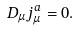Convert formula to latex. <formula><loc_0><loc_0><loc_500><loc_500>D _ { \mu } j _ { \mu } ^ { a } = 0 .</formula> 